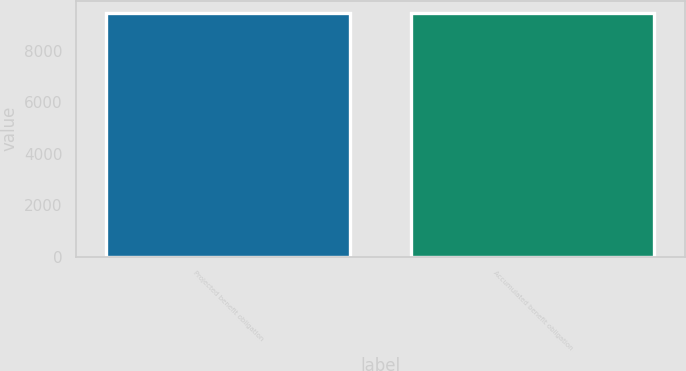Convert chart. <chart><loc_0><loc_0><loc_500><loc_500><bar_chart><fcel>Projected benefit obligation<fcel>Accumulated benefit obligation<nl><fcel>9469<fcel>9469.1<nl></chart> 